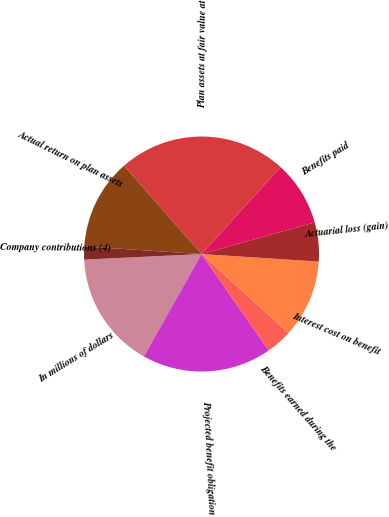Convert chart. <chart><loc_0><loc_0><loc_500><loc_500><pie_chart><fcel>In millions of dollars<fcel>Projected benefit obligation<fcel>Benefits earned during the<fcel>Interest cost on benefit<fcel>Actuarial loss (gain)<fcel>Benefits paid<fcel>Plan assets at fair value at<fcel>Actual return on plan assets<fcel>Company contributions (4)<nl><fcel>16.07%<fcel>17.85%<fcel>3.58%<fcel>10.71%<fcel>5.36%<fcel>8.93%<fcel>23.21%<fcel>12.5%<fcel>1.79%<nl></chart> 